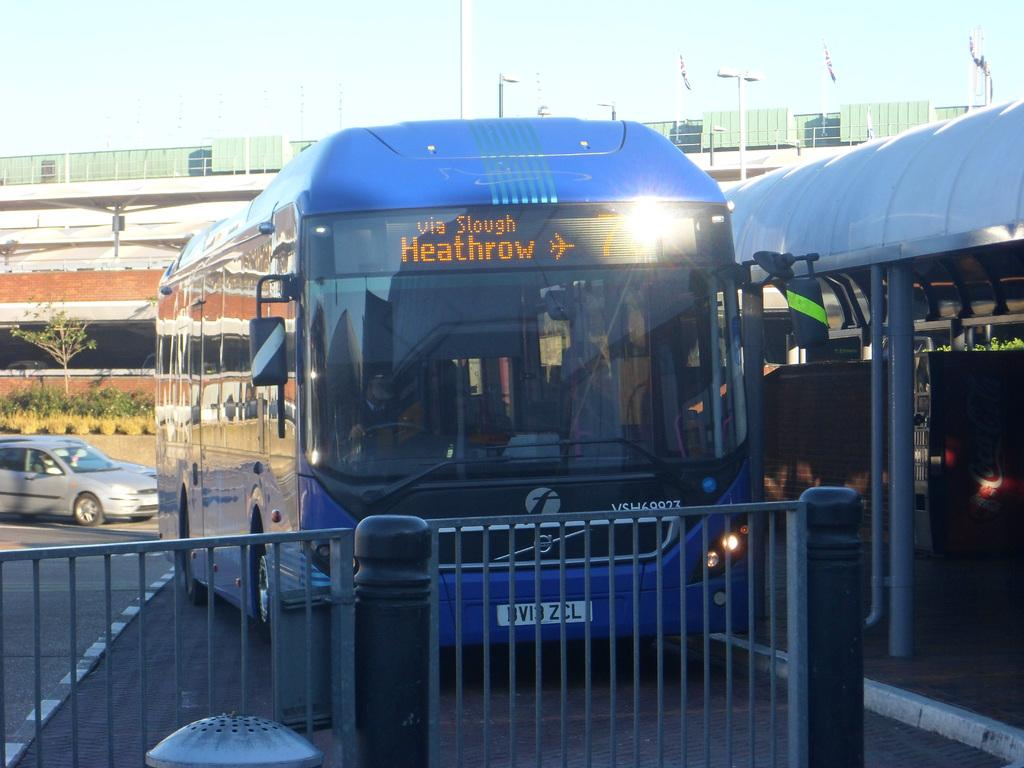<image>
Create a compact narrative representing the image presented. a blue bus to Heathrow airport is waiting for riders 